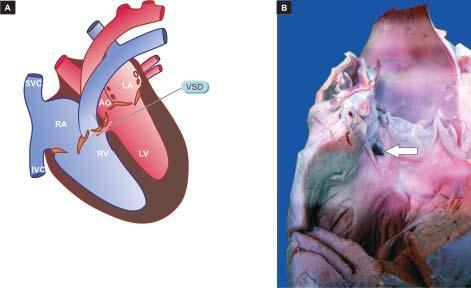do the opened up chambers of the heart show a communication in the inter-ventricular septum superiorly white arrow?
Answer the question using a single word or phrase. Yes 